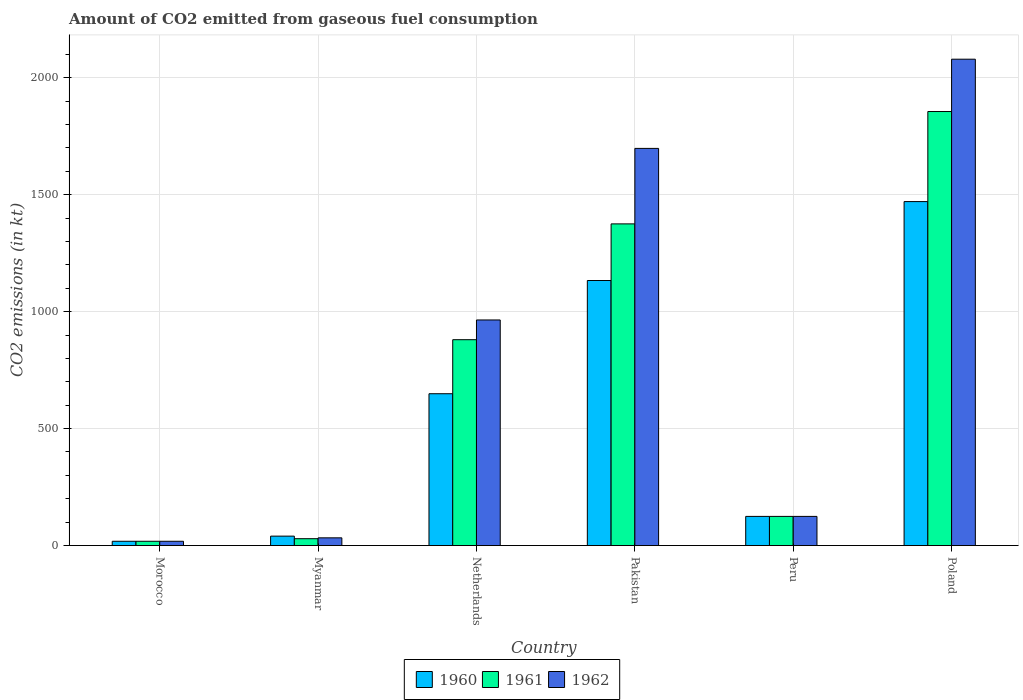Are the number of bars per tick equal to the number of legend labels?
Ensure brevity in your answer.  Yes. Are the number of bars on each tick of the X-axis equal?
Offer a terse response. Yes. What is the label of the 2nd group of bars from the left?
Keep it short and to the point. Myanmar. What is the amount of CO2 emitted in 1961 in Poland?
Your response must be concise. 1855.5. Across all countries, what is the maximum amount of CO2 emitted in 1960?
Ensure brevity in your answer.  1470.47. Across all countries, what is the minimum amount of CO2 emitted in 1962?
Offer a terse response. 18.34. In which country was the amount of CO2 emitted in 1962 minimum?
Keep it short and to the point. Morocco. What is the total amount of CO2 emitted in 1962 in the graph?
Provide a short and direct response. 4917.45. What is the difference between the amount of CO2 emitted in 1960 in Morocco and that in Netherlands?
Make the answer very short. -630.72. What is the difference between the amount of CO2 emitted in 1960 in Morocco and the amount of CO2 emitted in 1961 in Peru?
Give a very brief answer. -106.34. What is the average amount of CO2 emitted in 1962 per country?
Ensure brevity in your answer.  819.57. What is the difference between the amount of CO2 emitted of/in 1962 and amount of CO2 emitted of/in 1960 in Netherlands?
Offer a terse response. 315.36. What is the ratio of the amount of CO2 emitted in 1960 in Pakistan to that in Poland?
Ensure brevity in your answer.  0.77. What is the difference between the highest and the second highest amount of CO2 emitted in 1961?
Keep it short and to the point. -495.04. What is the difference between the highest and the lowest amount of CO2 emitted in 1960?
Keep it short and to the point. 1452.13. In how many countries, is the amount of CO2 emitted in 1962 greater than the average amount of CO2 emitted in 1962 taken over all countries?
Your response must be concise. 3. Is the sum of the amount of CO2 emitted in 1960 in Myanmar and Pakistan greater than the maximum amount of CO2 emitted in 1962 across all countries?
Keep it short and to the point. No. What does the 3rd bar from the left in Peru represents?
Give a very brief answer. 1962. Is it the case that in every country, the sum of the amount of CO2 emitted in 1962 and amount of CO2 emitted in 1960 is greater than the amount of CO2 emitted in 1961?
Offer a very short reply. Yes. What is the difference between two consecutive major ticks on the Y-axis?
Provide a short and direct response. 500. Does the graph contain grids?
Your answer should be very brief. Yes. What is the title of the graph?
Keep it short and to the point. Amount of CO2 emitted from gaseous fuel consumption. What is the label or title of the X-axis?
Provide a short and direct response. Country. What is the label or title of the Y-axis?
Keep it short and to the point. CO2 emissions (in kt). What is the CO2 emissions (in kt) in 1960 in Morocco?
Your response must be concise. 18.34. What is the CO2 emissions (in kt) of 1961 in Morocco?
Make the answer very short. 18.34. What is the CO2 emissions (in kt) in 1962 in Morocco?
Provide a succinct answer. 18.34. What is the CO2 emissions (in kt) of 1960 in Myanmar?
Offer a very short reply. 40.34. What is the CO2 emissions (in kt) of 1961 in Myanmar?
Provide a succinct answer. 29.34. What is the CO2 emissions (in kt) of 1962 in Myanmar?
Keep it short and to the point. 33. What is the CO2 emissions (in kt) of 1960 in Netherlands?
Offer a very short reply. 649.06. What is the CO2 emissions (in kt) in 1961 in Netherlands?
Your response must be concise. 880.08. What is the CO2 emissions (in kt) of 1962 in Netherlands?
Your answer should be compact. 964.42. What is the CO2 emissions (in kt) of 1960 in Pakistan?
Provide a short and direct response. 1133.1. What is the CO2 emissions (in kt) of 1961 in Pakistan?
Keep it short and to the point. 1375.12. What is the CO2 emissions (in kt) of 1962 in Pakistan?
Keep it short and to the point. 1697.82. What is the CO2 emissions (in kt) of 1960 in Peru?
Give a very brief answer. 124.68. What is the CO2 emissions (in kt) of 1961 in Peru?
Make the answer very short. 124.68. What is the CO2 emissions (in kt) of 1962 in Peru?
Your response must be concise. 124.68. What is the CO2 emissions (in kt) of 1960 in Poland?
Make the answer very short. 1470.47. What is the CO2 emissions (in kt) in 1961 in Poland?
Keep it short and to the point. 1855.5. What is the CO2 emissions (in kt) of 1962 in Poland?
Your response must be concise. 2079.19. Across all countries, what is the maximum CO2 emissions (in kt) in 1960?
Keep it short and to the point. 1470.47. Across all countries, what is the maximum CO2 emissions (in kt) in 1961?
Make the answer very short. 1855.5. Across all countries, what is the maximum CO2 emissions (in kt) in 1962?
Give a very brief answer. 2079.19. Across all countries, what is the minimum CO2 emissions (in kt) in 1960?
Provide a succinct answer. 18.34. Across all countries, what is the minimum CO2 emissions (in kt) in 1961?
Make the answer very short. 18.34. Across all countries, what is the minimum CO2 emissions (in kt) of 1962?
Offer a very short reply. 18.34. What is the total CO2 emissions (in kt) in 1960 in the graph?
Your answer should be very brief. 3435.98. What is the total CO2 emissions (in kt) of 1961 in the graph?
Your response must be concise. 4283.06. What is the total CO2 emissions (in kt) of 1962 in the graph?
Offer a very short reply. 4917.45. What is the difference between the CO2 emissions (in kt) in 1960 in Morocco and that in Myanmar?
Make the answer very short. -22. What is the difference between the CO2 emissions (in kt) of 1961 in Morocco and that in Myanmar?
Your answer should be compact. -11. What is the difference between the CO2 emissions (in kt) of 1962 in Morocco and that in Myanmar?
Ensure brevity in your answer.  -14.67. What is the difference between the CO2 emissions (in kt) of 1960 in Morocco and that in Netherlands?
Ensure brevity in your answer.  -630.72. What is the difference between the CO2 emissions (in kt) of 1961 in Morocco and that in Netherlands?
Give a very brief answer. -861.75. What is the difference between the CO2 emissions (in kt) of 1962 in Morocco and that in Netherlands?
Offer a very short reply. -946.09. What is the difference between the CO2 emissions (in kt) of 1960 in Morocco and that in Pakistan?
Offer a very short reply. -1114.77. What is the difference between the CO2 emissions (in kt) in 1961 in Morocco and that in Pakistan?
Your response must be concise. -1356.79. What is the difference between the CO2 emissions (in kt) in 1962 in Morocco and that in Pakistan?
Offer a very short reply. -1679.49. What is the difference between the CO2 emissions (in kt) of 1960 in Morocco and that in Peru?
Your response must be concise. -106.34. What is the difference between the CO2 emissions (in kt) of 1961 in Morocco and that in Peru?
Provide a short and direct response. -106.34. What is the difference between the CO2 emissions (in kt) of 1962 in Morocco and that in Peru?
Provide a short and direct response. -106.34. What is the difference between the CO2 emissions (in kt) in 1960 in Morocco and that in Poland?
Your answer should be compact. -1452.13. What is the difference between the CO2 emissions (in kt) of 1961 in Morocco and that in Poland?
Give a very brief answer. -1837.17. What is the difference between the CO2 emissions (in kt) of 1962 in Morocco and that in Poland?
Offer a terse response. -2060.85. What is the difference between the CO2 emissions (in kt) in 1960 in Myanmar and that in Netherlands?
Offer a very short reply. -608.72. What is the difference between the CO2 emissions (in kt) in 1961 in Myanmar and that in Netherlands?
Keep it short and to the point. -850.74. What is the difference between the CO2 emissions (in kt) of 1962 in Myanmar and that in Netherlands?
Keep it short and to the point. -931.42. What is the difference between the CO2 emissions (in kt) in 1960 in Myanmar and that in Pakistan?
Ensure brevity in your answer.  -1092.77. What is the difference between the CO2 emissions (in kt) of 1961 in Myanmar and that in Pakistan?
Provide a succinct answer. -1345.79. What is the difference between the CO2 emissions (in kt) in 1962 in Myanmar and that in Pakistan?
Give a very brief answer. -1664.82. What is the difference between the CO2 emissions (in kt) of 1960 in Myanmar and that in Peru?
Keep it short and to the point. -84.34. What is the difference between the CO2 emissions (in kt) in 1961 in Myanmar and that in Peru?
Keep it short and to the point. -95.34. What is the difference between the CO2 emissions (in kt) of 1962 in Myanmar and that in Peru?
Provide a succinct answer. -91.67. What is the difference between the CO2 emissions (in kt) of 1960 in Myanmar and that in Poland?
Ensure brevity in your answer.  -1430.13. What is the difference between the CO2 emissions (in kt) in 1961 in Myanmar and that in Poland?
Provide a succinct answer. -1826.17. What is the difference between the CO2 emissions (in kt) of 1962 in Myanmar and that in Poland?
Offer a terse response. -2046.19. What is the difference between the CO2 emissions (in kt) of 1960 in Netherlands and that in Pakistan?
Provide a short and direct response. -484.04. What is the difference between the CO2 emissions (in kt) of 1961 in Netherlands and that in Pakistan?
Make the answer very short. -495.05. What is the difference between the CO2 emissions (in kt) in 1962 in Netherlands and that in Pakistan?
Your answer should be compact. -733.4. What is the difference between the CO2 emissions (in kt) of 1960 in Netherlands and that in Peru?
Provide a short and direct response. 524.38. What is the difference between the CO2 emissions (in kt) of 1961 in Netherlands and that in Peru?
Keep it short and to the point. 755.4. What is the difference between the CO2 emissions (in kt) of 1962 in Netherlands and that in Peru?
Offer a terse response. 839.74. What is the difference between the CO2 emissions (in kt) in 1960 in Netherlands and that in Poland?
Offer a terse response. -821.41. What is the difference between the CO2 emissions (in kt) in 1961 in Netherlands and that in Poland?
Your response must be concise. -975.42. What is the difference between the CO2 emissions (in kt) in 1962 in Netherlands and that in Poland?
Give a very brief answer. -1114.77. What is the difference between the CO2 emissions (in kt) in 1960 in Pakistan and that in Peru?
Offer a terse response. 1008.42. What is the difference between the CO2 emissions (in kt) of 1961 in Pakistan and that in Peru?
Offer a terse response. 1250.45. What is the difference between the CO2 emissions (in kt) in 1962 in Pakistan and that in Peru?
Make the answer very short. 1573.14. What is the difference between the CO2 emissions (in kt) of 1960 in Pakistan and that in Poland?
Provide a short and direct response. -337.36. What is the difference between the CO2 emissions (in kt) of 1961 in Pakistan and that in Poland?
Make the answer very short. -480.38. What is the difference between the CO2 emissions (in kt) in 1962 in Pakistan and that in Poland?
Provide a short and direct response. -381.37. What is the difference between the CO2 emissions (in kt) of 1960 in Peru and that in Poland?
Offer a terse response. -1345.79. What is the difference between the CO2 emissions (in kt) of 1961 in Peru and that in Poland?
Provide a succinct answer. -1730.82. What is the difference between the CO2 emissions (in kt) in 1962 in Peru and that in Poland?
Make the answer very short. -1954.51. What is the difference between the CO2 emissions (in kt) of 1960 in Morocco and the CO2 emissions (in kt) of 1961 in Myanmar?
Your response must be concise. -11. What is the difference between the CO2 emissions (in kt) of 1960 in Morocco and the CO2 emissions (in kt) of 1962 in Myanmar?
Make the answer very short. -14.67. What is the difference between the CO2 emissions (in kt) in 1961 in Morocco and the CO2 emissions (in kt) in 1962 in Myanmar?
Your answer should be compact. -14.67. What is the difference between the CO2 emissions (in kt) of 1960 in Morocco and the CO2 emissions (in kt) of 1961 in Netherlands?
Provide a succinct answer. -861.75. What is the difference between the CO2 emissions (in kt) of 1960 in Morocco and the CO2 emissions (in kt) of 1962 in Netherlands?
Offer a terse response. -946.09. What is the difference between the CO2 emissions (in kt) of 1961 in Morocco and the CO2 emissions (in kt) of 1962 in Netherlands?
Give a very brief answer. -946.09. What is the difference between the CO2 emissions (in kt) of 1960 in Morocco and the CO2 emissions (in kt) of 1961 in Pakistan?
Your answer should be compact. -1356.79. What is the difference between the CO2 emissions (in kt) in 1960 in Morocco and the CO2 emissions (in kt) in 1962 in Pakistan?
Your answer should be compact. -1679.49. What is the difference between the CO2 emissions (in kt) in 1961 in Morocco and the CO2 emissions (in kt) in 1962 in Pakistan?
Your response must be concise. -1679.49. What is the difference between the CO2 emissions (in kt) of 1960 in Morocco and the CO2 emissions (in kt) of 1961 in Peru?
Provide a short and direct response. -106.34. What is the difference between the CO2 emissions (in kt) in 1960 in Morocco and the CO2 emissions (in kt) in 1962 in Peru?
Give a very brief answer. -106.34. What is the difference between the CO2 emissions (in kt) in 1961 in Morocco and the CO2 emissions (in kt) in 1962 in Peru?
Your answer should be very brief. -106.34. What is the difference between the CO2 emissions (in kt) of 1960 in Morocco and the CO2 emissions (in kt) of 1961 in Poland?
Your response must be concise. -1837.17. What is the difference between the CO2 emissions (in kt) of 1960 in Morocco and the CO2 emissions (in kt) of 1962 in Poland?
Offer a terse response. -2060.85. What is the difference between the CO2 emissions (in kt) of 1961 in Morocco and the CO2 emissions (in kt) of 1962 in Poland?
Make the answer very short. -2060.85. What is the difference between the CO2 emissions (in kt) in 1960 in Myanmar and the CO2 emissions (in kt) in 1961 in Netherlands?
Provide a short and direct response. -839.74. What is the difference between the CO2 emissions (in kt) in 1960 in Myanmar and the CO2 emissions (in kt) in 1962 in Netherlands?
Keep it short and to the point. -924.08. What is the difference between the CO2 emissions (in kt) of 1961 in Myanmar and the CO2 emissions (in kt) of 1962 in Netherlands?
Offer a very short reply. -935.09. What is the difference between the CO2 emissions (in kt) in 1960 in Myanmar and the CO2 emissions (in kt) in 1961 in Pakistan?
Your response must be concise. -1334.79. What is the difference between the CO2 emissions (in kt) in 1960 in Myanmar and the CO2 emissions (in kt) in 1962 in Pakistan?
Provide a succinct answer. -1657.48. What is the difference between the CO2 emissions (in kt) of 1961 in Myanmar and the CO2 emissions (in kt) of 1962 in Pakistan?
Ensure brevity in your answer.  -1668.48. What is the difference between the CO2 emissions (in kt) of 1960 in Myanmar and the CO2 emissions (in kt) of 1961 in Peru?
Keep it short and to the point. -84.34. What is the difference between the CO2 emissions (in kt) in 1960 in Myanmar and the CO2 emissions (in kt) in 1962 in Peru?
Your answer should be very brief. -84.34. What is the difference between the CO2 emissions (in kt) of 1961 in Myanmar and the CO2 emissions (in kt) of 1962 in Peru?
Your answer should be very brief. -95.34. What is the difference between the CO2 emissions (in kt) in 1960 in Myanmar and the CO2 emissions (in kt) in 1961 in Poland?
Keep it short and to the point. -1815.16. What is the difference between the CO2 emissions (in kt) in 1960 in Myanmar and the CO2 emissions (in kt) in 1962 in Poland?
Provide a succinct answer. -2038.85. What is the difference between the CO2 emissions (in kt) of 1961 in Myanmar and the CO2 emissions (in kt) of 1962 in Poland?
Offer a very short reply. -2049.85. What is the difference between the CO2 emissions (in kt) in 1960 in Netherlands and the CO2 emissions (in kt) in 1961 in Pakistan?
Offer a terse response. -726.07. What is the difference between the CO2 emissions (in kt) in 1960 in Netherlands and the CO2 emissions (in kt) in 1962 in Pakistan?
Offer a terse response. -1048.76. What is the difference between the CO2 emissions (in kt) in 1961 in Netherlands and the CO2 emissions (in kt) in 1962 in Pakistan?
Make the answer very short. -817.74. What is the difference between the CO2 emissions (in kt) in 1960 in Netherlands and the CO2 emissions (in kt) in 1961 in Peru?
Your response must be concise. 524.38. What is the difference between the CO2 emissions (in kt) in 1960 in Netherlands and the CO2 emissions (in kt) in 1962 in Peru?
Make the answer very short. 524.38. What is the difference between the CO2 emissions (in kt) of 1961 in Netherlands and the CO2 emissions (in kt) of 1962 in Peru?
Give a very brief answer. 755.4. What is the difference between the CO2 emissions (in kt) in 1960 in Netherlands and the CO2 emissions (in kt) in 1961 in Poland?
Provide a short and direct response. -1206.44. What is the difference between the CO2 emissions (in kt) in 1960 in Netherlands and the CO2 emissions (in kt) in 1962 in Poland?
Make the answer very short. -1430.13. What is the difference between the CO2 emissions (in kt) of 1961 in Netherlands and the CO2 emissions (in kt) of 1962 in Poland?
Your response must be concise. -1199.11. What is the difference between the CO2 emissions (in kt) in 1960 in Pakistan and the CO2 emissions (in kt) in 1961 in Peru?
Your answer should be compact. 1008.42. What is the difference between the CO2 emissions (in kt) in 1960 in Pakistan and the CO2 emissions (in kt) in 1962 in Peru?
Ensure brevity in your answer.  1008.42. What is the difference between the CO2 emissions (in kt) of 1961 in Pakistan and the CO2 emissions (in kt) of 1962 in Peru?
Your answer should be compact. 1250.45. What is the difference between the CO2 emissions (in kt) in 1960 in Pakistan and the CO2 emissions (in kt) in 1961 in Poland?
Offer a very short reply. -722.4. What is the difference between the CO2 emissions (in kt) in 1960 in Pakistan and the CO2 emissions (in kt) in 1962 in Poland?
Your answer should be compact. -946.09. What is the difference between the CO2 emissions (in kt) in 1961 in Pakistan and the CO2 emissions (in kt) in 1962 in Poland?
Your answer should be very brief. -704.06. What is the difference between the CO2 emissions (in kt) in 1960 in Peru and the CO2 emissions (in kt) in 1961 in Poland?
Make the answer very short. -1730.82. What is the difference between the CO2 emissions (in kt) in 1960 in Peru and the CO2 emissions (in kt) in 1962 in Poland?
Your answer should be very brief. -1954.51. What is the difference between the CO2 emissions (in kt) of 1961 in Peru and the CO2 emissions (in kt) of 1962 in Poland?
Offer a very short reply. -1954.51. What is the average CO2 emissions (in kt) in 1960 per country?
Keep it short and to the point. 572.66. What is the average CO2 emissions (in kt) of 1961 per country?
Offer a very short reply. 713.84. What is the average CO2 emissions (in kt) in 1962 per country?
Give a very brief answer. 819.57. What is the difference between the CO2 emissions (in kt) of 1960 and CO2 emissions (in kt) of 1962 in Morocco?
Make the answer very short. 0. What is the difference between the CO2 emissions (in kt) of 1961 and CO2 emissions (in kt) of 1962 in Morocco?
Your response must be concise. 0. What is the difference between the CO2 emissions (in kt) in 1960 and CO2 emissions (in kt) in 1961 in Myanmar?
Offer a very short reply. 11. What is the difference between the CO2 emissions (in kt) in 1960 and CO2 emissions (in kt) in 1962 in Myanmar?
Your response must be concise. 7.33. What is the difference between the CO2 emissions (in kt) in 1961 and CO2 emissions (in kt) in 1962 in Myanmar?
Offer a very short reply. -3.67. What is the difference between the CO2 emissions (in kt) of 1960 and CO2 emissions (in kt) of 1961 in Netherlands?
Provide a short and direct response. -231.02. What is the difference between the CO2 emissions (in kt) of 1960 and CO2 emissions (in kt) of 1962 in Netherlands?
Make the answer very short. -315.36. What is the difference between the CO2 emissions (in kt) in 1961 and CO2 emissions (in kt) in 1962 in Netherlands?
Make the answer very short. -84.34. What is the difference between the CO2 emissions (in kt) of 1960 and CO2 emissions (in kt) of 1961 in Pakistan?
Provide a short and direct response. -242.02. What is the difference between the CO2 emissions (in kt) in 1960 and CO2 emissions (in kt) in 1962 in Pakistan?
Keep it short and to the point. -564.72. What is the difference between the CO2 emissions (in kt) in 1961 and CO2 emissions (in kt) in 1962 in Pakistan?
Your answer should be compact. -322.7. What is the difference between the CO2 emissions (in kt) of 1960 and CO2 emissions (in kt) of 1961 in Peru?
Your answer should be compact. 0. What is the difference between the CO2 emissions (in kt) of 1960 and CO2 emissions (in kt) of 1961 in Poland?
Offer a very short reply. -385.04. What is the difference between the CO2 emissions (in kt) of 1960 and CO2 emissions (in kt) of 1962 in Poland?
Your answer should be compact. -608.72. What is the difference between the CO2 emissions (in kt) in 1961 and CO2 emissions (in kt) in 1962 in Poland?
Offer a very short reply. -223.69. What is the ratio of the CO2 emissions (in kt) of 1960 in Morocco to that in Myanmar?
Offer a very short reply. 0.45. What is the ratio of the CO2 emissions (in kt) in 1961 in Morocco to that in Myanmar?
Provide a succinct answer. 0.62. What is the ratio of the CO2 emissions (in kt) of 1962 in Morocco to that in Myanmar?
Keep it short and to the point. 0.56. What is the ratio of the CO2 emissions (in kt) in 1960 in Morocco to that in Netherlands?
Ensure brevity in your answer.  0.03. What is the ratio of the CO2 emissions (in kt) of 1961 in Morocco to that in Netherlands?
Give a very brief answer. 0.02. What is the ratio of the CO2 emissions (in kt) in 1962 in Morocco to that in Netherlands?
Provide a short and direct response. 0.02. What is the ratio of the CO2 emissions (in kt) in 1960 in Morocco to that in Pakistan?
Offer a terse response. 0.02. What is the ratio of the CO2 emissions (in kt) of 1961 in Morocco to that in Pakistan?
Your answer should be compact. 0.01. What is the ratio of the CO2 emissions (in kt) of 1962 in Morocco to that in Pakistan?
Provide a short and direct response. 0.01. What is the ratio of the CO2 emissions (in kt) of 1960 in Morocco to that in Peru?
Provide a short and direct response. 0.15. What is the ratio of the CO2 emissions (in kt) of 1961 in Morocco to that in Peru?
Keep it short and to the point. 0.15. What is the ratio of the CO2 emissions (in kt) in 1962 in Morocco to that in Peru?
Provide a succinct answer. 0.15. What is the ratio of the CO2 emissions (in kt) of 1960 in Morocco to that in Poland?
Keep it short and to the point. 0.01. What is the ratio of the CO2 emissions (in kt) in 1961 in Morocco to that in Poland?
Your answer should be very brief. 0.01. What is the ratio of the CO2 emissions (in kt) of 1962 in Morocco to that in Poland?
Offer a very short reply. 0.01. What is the ratio of the CO2 emissions (in kt) of 1960 in Myanmar to that in Netherlands?
Keep it short and to the point. 0.06. What is the ratio of the CO2 emissions (in kt) in 1961 in Myanmar to that in Netherlands?
Offer a very short reply. 0.03. What is the ratio of the CO2 emissions (in kt) in 1962 in Myanmar to that in Netherlands?
Make the answer very short. 0.03. What is the ratio of the CO2 emissions (in kt) of 1960 in Myanmar to that in Pakistan?
Ensure brevity in your answer.  0.04. What is the ratio of the CO2 emissions (in kt) of 1961 in Myanmar to that in Pakistan?
Offer a very short reply. 0.02. What is the ratio of the CO2 emissions (in kt) of 1962 in Myanmar to that in Pakistan?
Offer a terse response. 0.02. What is the ratio of the CO2 emissions (in kt) of 1960 in Myanmar to that in Peru?
Offer a very short reply. 0.32. What is the ratio of the CO2 emissions (in kt) in 1961 in Myanmar to that in Peru?
Offer a very short reply. 0.24. What is the ratio of the CO2 emissions (in kt) in 1962 in Myanmar to that in Peru?
Make the answer very short. 0.26. What is the ratio of the CO2 emissions (in kt) of 1960 in Myanmar to that in Poland?
Your response must be concise. 0.03. What is the ratio of the CO2 emissions (in kt) in 1961 in Myanmar to that in Poland?
Provide a succinct answer. 0.02. What is the ratio of the CO2 emissions (in kt) of 1962 in Myanmar to that in Poland?
Your answer should be very brief. 0.02. What is the ratio of the CO2 emissions (in kt) of 1960 in Netherlands to that in Pakistan?
Offer a very short reply. 0.57. What is the ratio of the CO2 emissions (in kt) of 1961 in Netherlands to that in Pakistan?
Keep it short and to the point. 0.64. What is the ratio of the CO2 emissions (in kt) in 1962 in Netherlands to that in Pakistan?
Keep it short and to the point. 0.57. What is the ratio of the CO2 emissions (in kt) of 1960 in Netherlands to that in Peru?
Keep it short and to the point. 5.21. What is the ratio of the CO2 emissions (in kt) in 1961 in Netherlands to that in Peru?
Your answer should be very brief. 7.06. What is the ratio of the CO2 emissions (in kt) in 1962 in Netherlands to that in Peru?
Ensure brevity in your answer.  7.74. What is the ratio of the CO2 emissions (in kt) of 1960 in Netherlands to that in Poland?
Your answer should be compact. 0.44. What is the ratio of the CO2 emissions (in kt) of 1961 in Netherlands to that in Poland?
Provide a short and direct response. 0.47. What is the ratio of the CO2 emissions (in kt) in 1962 in Netherlands to that in Poland?
Offer a very short reply. 0.46. What is the ratio of the CO2 emissions (in kt) of 1960 in Pakistan to that in Peru?
Give a very brief answer. 9.09. What is the ratio of the CO2 emissions (in kt) in 1961 in Pakistan to that in Peru?
Your response must be concise. 11.03. What is the ratio of the CO2 emissions (in kt) in 1962 in Pakistan to that in Peru?
Give a very brief answer. 13.62. What is the ratio of the CO2 emissions (in kt) in 1960 in Pakistan to that in Poland?
Make the answer very short. 0.77. What is the ratio of the CO2 emissions (in kt) in 1961 in Pakistan to that in Poland?
Offer a very short reply. 0.74. What is the ratio of the CO2 emissions (in kt) in 1962 in Pakistan to that in Poland?
Your response must be concise. 0.82. What is the ratio of the CO2 emissions (in kt) of 1960 in Peru to that in Poland?
Give a very brief answer. 0.08. What is the ratio of the CO2 emissions (in kt) of 1961 in Peru to that in Poland?
Offer a terse response. 0.07. What is the difference between the highest and the second highest CO2 emissions (in kt) of 1960?
Your answer should be very brief. 337.36. What is the difference between the highest and the second highest CO2 emissions (in kt) of 1961?
Give a very brief answer. 480.38. What is the difference between the highest and the second highest CO2 emissions (in kt) in 1962?
Your answer should be compact. 381.37. What is the difference between the highest and the lowest CO2 emissions (in kt) in 1960?
Keep it short and to the point. 1452.13. What is the difference between the highest and the lowest CO2 emissions (in kt) of 1961?
Provide a short and direct response. 1837.17. What is the difference between the highest and the lowest CO2 emissions (in kt) of 1962?
Keep it short and to the point. 2060.85. 